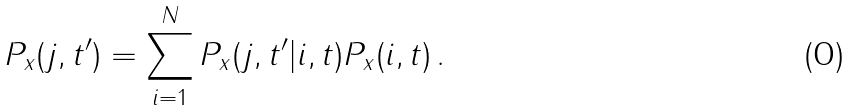Convert formula to latex. <formula><loc_0><loc_0><loc_500><loc_500>P _ { x } ( j , t ^ { \prime } ) = \sum _ { i = 1 } ^ { N } P _ { x } ( j , t ^ { \prime } | i , t ) P _ { x } ( i , t ) \, .</formula> 